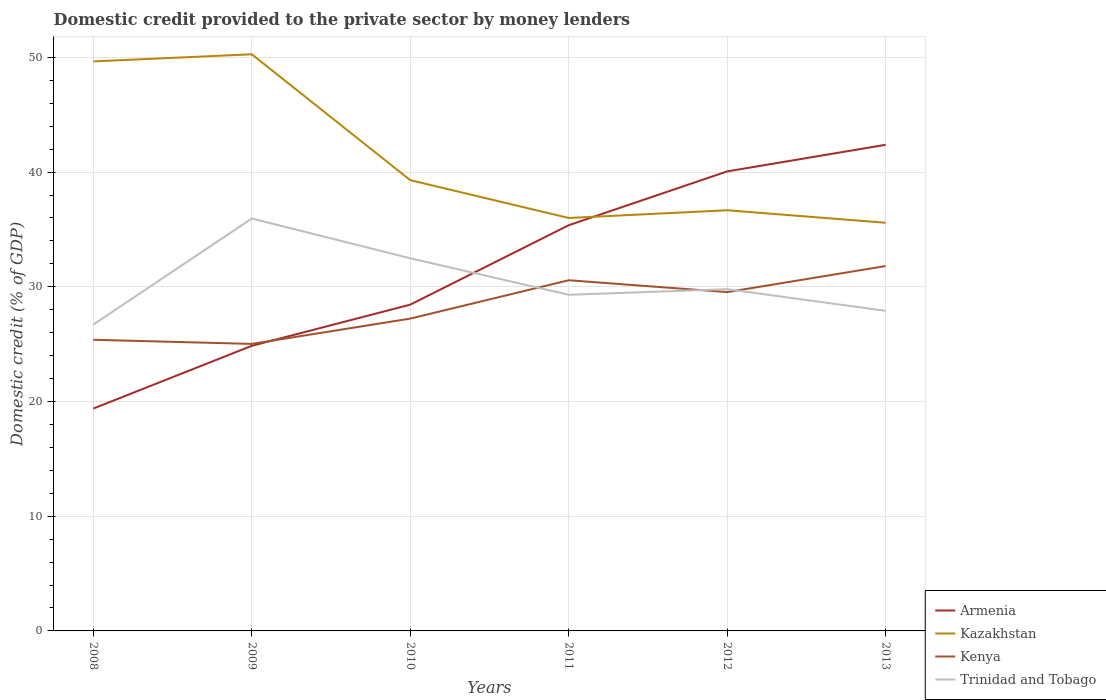Is the number of lines equal to the number of legend labels?
Your answer should be very brief. Yes. Across all years, what is the maximum domestic credit provided to the private sector by money lenders in Kazakhstan?
Give a very brief answer. 35.58. What is the total domestic credit provided to the private sector by money lenders in Kazakhstan in the graph?
Provide a succinct answer. 14.27. What is the difference between the highest and the second highest domestic credit provided to the private sector by money lenders in Armenia?
Give a very brief answer. 22.99. How many lines are there?
Provide a short and direct response. 4. How are the legend labels stacked?
Ensure brevity in your answer.  Vertical. What is the title of the graph?
Ensure brevity in your answer.  Domestic credit provided to the private sector by money lenders. Does "Sint Maarten (Dutch part)" appear as one of the legend labels in the graph?
Your answer should be very brief. No. What is the label or title of the X-axis?
Keep it short and to the point. Years. What is the label or title of the Y-axis?
Your answer should be very brief. Domestic credit (% of GDP). What is the Domestic credit (% of GDP) of Armenia in 2008?
Keep it short and to the point. 19.39. What is the Domestic credit (% of GDP) of Kazakhstan in 2008?
Your answer should be very brief. 49.65. What is the Domestic credit (% of GDP) in Kenya in 2008?
Give a very brief answer. 25.38. What is the Domestic credit (% of GDP) of Trinidad and Tobago in 2008?
Provide a succinct answer. 26.71. What is the Domestic credit (% of GDP) in Armenia in 2009?
Provide a succinct answer. 24.85. What is the Domestic credit (% of GDP) of Kazakhstan in 2009?
Provide a short and direct response. 50.27. What is the Domestic credit (% of GDP) in Kenya in 2009?
Keep it short and to the point. 25.02. What is the Domestic credit (% of GDP) of Trinidad and Tobago in 2009?
Offer a very short reply. 35.95. What is the Domestic credit (% of GDP) of Armenia in 2010?
Offer a very short reply. 28.45. What is the Domestic credit (% of GDP) of Kazakhstan in 2010?
Your answer should be very brief. 39.3. What is the Domestic credit (% of GDP) of Kenya in 2010?
Give a very brief answer. 27.23. What is the Domestic credit (% of GDP) of Trinidad and Tobago in 2010?
Your answer should be very brief. 32.49. What is the Domestic credit (% of GDP) of Armenia in 2011?
Keep it short and to the point. 35.37. What is the Domestic credit (% of GDP) of Kazakhstan in 2011?
Ensure brevity in your answer.  36. What is the Domestic credit (% of GDP) in Kenya in 2011?
Your answer should be compact. 30.57. What is the Domestic credit (% of GDP) in Trinidad and Tobago in 2011?
Provide a succinct answer. 29.3. What is the Domestic credit (% of GDP) in Armenia in 2012?
Your answer should be compact. 40.06. What is the Domestic credit (% of GDP) in Kazakhstan in 2012?
Provide a short and direct response. 36.67. What is the Domestic credit (% of GDP) in Kenya in 2012?
Ensure brevity in your answer.  29.54. What is the Domestic credit (% of GDP) of Trinidad and Tobago in 2012?
Give a very brief answer. 29.79. What is the Domestic credit (% of GDP) in Armenia in 2013?
Ensure brevity in your answer.  42.38. What is the Domestic credit (% of GDP) in Kazakhstan in 2013?
Make the answer very short. 35.58. What is the Domestic credit (% of GDP) in Kenya in 2013?
Make the answer very short. 31.81. What is the Domestic credit (% of GDP) in Trinidad and Tobago in 2013?
Provide a short and direct response. 27.91. Across all years, what is the maximum Domestic credit (% of GDP) in Armenia?
Offer a terse response. 42.38. Across all years, what is the maximum Domestic credit (% of GDP) of Kazakhstan?
Your answer should be compact. 50.27. Across all years, what is the maximum Domestic credit (% of GDP) in Kenya?
Provide a short and direct response. 31.81. Across all years, what is the maximum Domestic credit (% of GDP) of Trinidad and Tobago?
Your response must be concise. 35.95. Across all years, what is the minimum Domestic credit (% of GDP) of Armenia?
Offer a very short reply. 19.39. Across all years, what is the minimum Domestic credit (% of GDP) of Kazakhstan?
Keep it short and to the point. 35.58. Across all years, what is the minimum Domestic credit (% of GDP) in Kenya?
Your answer should be very brief. 25.02. Across all years, what is the minimum Domestic credit (% of GDP) in Trinidad and Tobago?
Provide a short and direct response. 26.71. What is the total Domestic credit (% of GDP) of Armenia in the graph?
Keep it short and to the point. 190.5. What is the total Domestic credit (% of GDP) in Kazakhstan in the graph?
Make the answer very short. 247.47. What is the total Domestic credit (% of GDP) of Kenya in the graph?
Make the answer very short. 169.55. What is the total Domestic credit (% of GDP) of Trinidad and Tobago in the graph?
Provide a succinct answer. 182.15. What is the difference between the Domestic credit (% of GDP) in Armenia in 2008 and that in 2009?
Provide a short and direct response. -5.47. What is the difference between the Domestic credit (% of GDP) in Kazakhstan in 2008 and that in 2009?
Provide a succinct answer. -0.62. What is the difference between the Domestic credit (% of GDP) in Kenya in 2008 and that in 2009?
Your response must be concise. 0.36. What is the difference between the Domestic credit (% of GDP) in Trinidad and Tobago in 2008 and that in 2009?
Your answer should be very brief. -9.25. What is the difference between the Domestic credit (% of GDP) in Armenia in 2008 and that in 2010?
Make the answer very short. -9.06. What is the difference between the Domestic credit (% of GDP) in Kazakhstan in 2008 and that in 2010?
Offer a very short reply. 10.35. What is the difference between the Domestic credit (% of GDP) in Kenya in 2008 and that in 2010?
Provide a short and direct response. -1.85. What is the difference between the Domestic credit (% of GDP) of Trinidad and Tobago in 2008 and that in 2010?
Offer a terse response. -5.78. What is the difference between the Domestic credit (% of GDP) in Armenia in 2008 and that in 2011?
Provide a short and direct response. -15.98. What is the difference between the Domestic credit (% of GDP) in Kazakhstan in 2008 and that in 2011?
Provide a short and direct response. 13.65. What is the difference between the Domestic credit (% of GDP) in Kenya in 2008 and that in 2011?
Keep it short and to the point. -5.19. What is the difference between the Domestic credit (% of GDP) in Trinidad and Tobago in 2008 and that in 2011?
Provide a succinct answer. -2.6. What is the difference between the Domestic credit (% of GDP) in Armenia in 2008 and that in 2012?
Ensure brevity in your answer.  -20.67. What is the difference between the Domestic credit (% of GDP) of Kazakhstan in 2008 and that in 2012?
Your answer should be very brief. 12.97. What is the difference between the Domestic credit (% of GDP) of Kenya in 2008 and that in 2012?
Your answer should be very brief. -4.16. What is the difference between the Domestic credit (% of GDP) in Trinidad and Tobago in 2008 and that in 2012?
Offer a terse response. -3.08. What is the difference between the Domestic credit (% of GDP) of Armenia in 2008 and that in 2013?
Your answer should be compact. -22.99. What is the difference between the Domestic credit (% of GDP) of Kazakhstan in 2008 and that in 2013?
Your answer should be very brief. 14.07. What is the difference between the Domestic credit (% of GDP) of Kenya in 2008 and that in 2013?
Provide a succinct answer. -6.43. What is the difference between the Domestic credit (% of GDP) of Trinidad and Tobago in 2008 and that in 2013?
Provide a short and direct response. -1.2. What is the difference between the Domestic credit (% of GDP) of Armenia in 2009 and that in 2010?
Your answer should be very brief. -3.59. What is the difference between the Domestic credit (% of GDP) of Kazakhstan in 2009 and that in 2010?
Provide a short and direct response. 10.97. What is the difference between the Domestic credit (% of GDP) of Kenya in 2009 and that in 2010?
Offer a very short reply. -2.21. What is the difference between the Domestic credit (% of GDP) in Trinidad and Tobago in 2009 and that in 2010?
Provide a short and direct response. 3.47. What is the difference between the Domestic credit (% of GDP) in Armenia in 2009 and that in 2011?
Make the answer very short. -10.51. What is the difference between the Domestic credit (% of GDP) of Kazakhstan in 2009 and that in 2011?
Ensure brevity in your answer.  14.27. What is the difference between the Domestic credit (% of GDP) of Kenya in 2009 and that in 2011?
Offer a terse response. -5.55. What is the difference between the Domestic credit (% of GDP) in Trinidad and Tobago in 2009 and that in 2011?
Give a very brief answer. 6.65. What is the difference between the Domestic credit (% of GDP) of Armenia in 2009 and that in 2012?
Your answer should be very brief. -15.21. What is the difference between the Domestic credit (% of GDP) in Kazakhstan in 2009 and that in 2012?
Ensure brevity in your answer.  13.6. What is the difference between the Domestic credit (% of GDP) in Kenya in 2009 and that in 2012?
Offer a very short reply. -4.52. What is the difference between the Domestic credit (% of GDP) of Trinidad and Tobago in 2009 and that in 2012?
Make the answer very short. 6.16. What is the difference between the Domestic credit (% of GDP) of Armenia in 2009 and that in 2013?
Offer a very short reply. -17.53. What is the difference between the Domestic credit (% of GDP) of Kazakhstan in 2009 and that in 2013?
Your answer should be very brief. 14.69. What is the difference between the Domestic credit (% of GDP) of Kenya in 2009 and that in 2013?
Ensure brevity in your answer.  -6.79. What is the difference between the Domestic credit (% of GDP) in Trinidad and Tobago in 2009 and that in 2013?
Make the answer very short. 8.05. What is the difference between the Domestic credit (% of GDP) in Armenia in 2010 and that in 2011?
Ensure brevity in your answer.  -6.92. What is the difference between the Domestic credit (% of GDP) of Kazakhstan in 2010 and that in 2011?
Provide a succinct answer. 3.3. What is the difference between the Domestic credit (% of GDP) in Kenya in 2010 and that in 2011?
Your answer should be very brief. -3.34. What is the difference between the Domestic credit (% of GDP) of Trinidad and Tobago in 2010 and that in 2011?
Your answer should be compact. 3.18. What is the difference between the Domestic credit (% of GDP) of Armenia in 2010 and that in 2012?
Your answer should be compact. -11.61. What is the difference between the Domestic credit (% of GDP) of Kazakhstan in 2010 and that in 2012?
Provide a succinct answer. 2.62. What is the difference between the Domestic credit (% of GDP) of Kenya in 2010 and that in 2012?
Make the answer very short. -2.31. What is the difference between the Domestic credit (% of GDP) in Trinidad and Tobago in 2010 and that in 2012?
Provide a succinct answer. 2.7. What is the difference between the Domestic credit (% of GDP) of Armenia in 2010 and that in 2013?
Your answer should be very brief. -13.94. What is the difference between the Domestic credit (% of GDP) in Kazakhstan in 2010 and that in 2013?
Offer a very short reply. 3.71. What is the difference between the Domestic credit (% of GDP) of Kenya in 2010 and that in 2013?
Offer a terse response. -4.58. What is the difference between the Domestic credit (% of GDP) of Trinidad and Tobago in 2010 and that in 2013?
Keep it short and to the point. 4.58. What is the difference between the Domestic credit (% of GDP) in Armenia in 2011 and that in 2012?
Offer a very short reply. -4.69. What is the difference between the Domestic credit (% of GDP) of Kazakhstan in 2011 and that in 2012?
Offer a terse response. -0.67. What is the difference between the Domestic credit (% of GDP) of Kenya in 2011 and that in 2012?
Make the answer very short. 1.03. What is the difference between the Domestic credit (% of GDP) in Trinidad and Tobago in 2011 and that in 2012?
Offer a very short reply. -0.49. What is the difference between the Domestic credit (% of GDP) in Armenia in 2011 and that in 2013?
Ensure brevity in your answer.  -7.01. What is the difference between the Domestic credit (% of GDP) of Kazakhstan in 2011 and that in 2013?
Offer a terse response. 0.42. What is the difference between the Domestic credit (% of GDP) of Kenya in 2011 and that in 2013?
Your answer should be very brief. -1.24. What is the difference between the Domestic credit (% of GDP) in Trinidad and Tobago in 2011 and that in 2013?
Your answer should be very brief. 1.4. What is the difference between the Domestic credit (% of GDP) of Armenia in 2012 and that in 2013?
Provide a succinct answer. -2.32. What is the difference between the Domestic credit (% of GDP) in Kazakhstan in 2012 and that in 2013?
Your response must be concise. 1.09. What is the difference between the Domestic credit (% of GDP) of Kenya in 2012 and that in 2013?
Provide a short and direct response. -2.27. What is the difference between the Domestic credit (% of GDP) in Trinidad and Tobago in 2012 and that in 2013?
Your answer should be compact. 1.88. What is the difference between the Domestic credit (% of GDP) in Armenia in 2008 and the Domestic credit (% of GDP) in Kazakhstan in 2009?
Your response must be concise. -30.88. What is the difference between the Domestic credit (% of GDP) in Armenia in 2008 and the Domestic credit (% of GDP) in Kenya in 2009?
Make the answer very short. -5.63. What is the difference between the Domestic credit (% of GDP) in Armenia in 2008 and the Domestic credit (% of GDP) in Trinidad and Tobago in 2009?
Your answer should be compact. -16.57. What is the difference between the Domestic credit (% of GDP) in Kazakhstan in 2008 and the Domestic credit (% of GDP) in Kenya in 2009?
Ensure brevity in your answer.  24.63. What is the difference between the Domestic credit (% of GDP) in Kazakhstan in 2008 and the Domestic credit (% of GDP) in Trinidad and Tobago in 2009?
Ensure brevity in your answer.  13.69. What is the difference between the Domestic credit (% of GDP) of Kenya in 2008 and the Domestic credit (% of GDP) of Trinidad and Tobago in 2009?
Make the answer very short. -10.57. What is the difference between the Domestic credit (% of GDP) of Armenia in 2008 and the Domestic credit (% of GDP) of Kazakhstan in 2010?
Give a very brief answer. -19.91. What is the difference between the Domestic credit (% of GDP) of Armenia in 2008 and the Domestic credit (% of GDP) of Kenya in 2010?
Provide a short and direct response. -7.84. What is the difference between the Domestic credit (% of GDP) of Armenia in 2008 and the Domestic credit (% of GDP) of Trinidad and Tobago in 2010?
Offer a terse response. -13.1. What is the difference between the Domestic credit (% of GDP) of Kazakhstan in 2008 and the Domestic credit (% of GDP) of Kenya in 2010?
Provide a short and direct response. 22.42. What is the difference between the Domestic credit (% of GDP) of Kazakhstan in 2008 and the Domestic credit (% of GDP) of Trinidad and Tobago in 2010?
Your response must be concise. 17.16. What is the difference between the Domestic credit (% of GDP) of Kenya in 2008 and the Domestic credit (% of GDP) of Trinidad and Tobago in 2010?
Your answer should be very brief. -7.11. What is the difference between the Domestic credit (% of GDP) of Armenia in 2008 and the Domestic credit (% of GDP) of Kazakhstan in 2011?
Give a very brief answer. -16.61. What is the difference between the Domestic credit (% of GDP) in Armenia in 2008 and the Domestic credit (% of GDP) in Kenya in 2011?
Make the answer very short. -11.19. What is the difference between the Domestic credit (% of GDP) in Armenia in 2008 and the Domestic credit (% of GDP) in Trinidad and Tobago in 2011?
Keep it short and to the point. -9.92. What is the difference between the Domestic credit (% of GDP) in Kazakhstan in 2008 and the Domestic credit (% of GDP) in Kenya in 2011?
Make the answer very short. 19.07. What is the difference between the Domestic credit (% of GDP) in Kazakhstan in 2008 and the Domestic credit (% of GDP) in Trinidad and Tobago in 2011?
Your answer should be compact. 20.34. What is the difference between the Domestic credit (% of GDP) in Kenya in 2008 and the Domestic credit (% of GDP) in Trinidad and Tobago in 2011?
Provide a short and direct response. -3.92. What is the difference between the Domestic credit (% of GDP) of Armenia in 2008 and the Domestic credit (% of GDP) of Kazakhstan in 2012?
Provide a short and direct response. -17.29. What is the difference between the Domestic credit (% of GDP) of Armenia in 2008 and the Domestic credit (% of GDP) of Kenya in 2012?
Make the answer very short. -10.15. What is the difference between the Domestic credit (% of GDP) in Armenia in 2008 and the Domestic credit (% of GDP) in Trinidad and Tobago in 2012?
Provide a short and direct response. -10.4. What is the difference between the Domestic credit (% of GDP) of Kazakhstan in 2008 and the Domestic credit (% of GDP) of Kenya in 2012?
Your answer should be compact. 20.11. What is the difference between the Domestic credit (% of GDP) in Kazakhstan in 2008 and the Domestic credit (% of GDP) in Trinidad and Tobago in 2012?
Your response must be concise. 19.86. What is the difference between the Domestic credit (% of GDP) in Kenya in 2008 and the Domestic credit (% of GDP) in Trinidad and Tobago in 2012?
Provide a short and direct response. -4.41. What is the difference between the Domestic credit (% of GDP) of Armenia in 2008 and the Domestic credit (% of GDP) of Kazakhstan in 2013?
Ensure brevity in your answer.  -16.2. What is the difference between the Domestic credit (% of GDP) of Armenia in 2008 and the Domestic credit (% of GDP) of Kenya in 2013?
Offer a terse response. -12.42. What is the difference between the Domestic credit (% of GDP) of Armenia in 2008 and the Domestic credit (% of GDP) of Trinidad and Tobago in 2013?
Ensure brevity in your answer.  -8.52. What is the difference between the Domestic credit (% of GDP) of Kazakhstan in 2008 and the Domestic credit (% of GDP) of Kenya in 2013?
Your answer should be compact. 17.84. What is the difference between the Domestic credit (% of GDP) in Kazakhstan in 2008 and the Domestic credit (% of GDP) in Trinidad and Tobago in 2013?
Ensure brevity in your answer.  21.74. What is the difference between the Domestic credit (% of GDP) of Kenya in 2008 and the Domestic credit (% of GDP) of Trinidad and Tobago in 2013?
Your answer should be very brief. -2.52. What is the difference between the Domestic credit (% of GDP) in Armenia in 2009 and the Domestic credit (% of GDP) in Kazakhstan in 2010?
Your response must be concise. -14.44. What is the difference between the Domestic credit (% of GDP) of Armenia in 2009 and the Domestic credit (% of GDP) of Kenya in 2010?
Offer a terse response. -2.37. What is the difference between the Domestic credit (% of GDP) of Armenia in 2009 and the Domestic credit (% of GDP) of Trinidad and Tobago in 2010?
Keep it short and to the point. -7.63. What is the difference between the Domestic credit (% of GDP) of Kazakhstan in 2009 and the Domestic credit (% of GDP) of Kenya in 2010?
Your answer should be very brief. 23.04. What is the difference between the Domestic credit (% of GDP) in Kazakhstan in 2009 and the Domestic credit (% of GDP) in Trinidad and Tobago in 2010?
Offer a terse response. 17.78. What is the difference between the Domestic credit (% of GDP) of Kenya in 2009 and the Domestic credit (% of GDP) of Trinidad and Tobago in 2010?
Provide a succinct answer. -7.47. What is the difference between the Domestic credit (% of GDP) of Armenia in 2009 and the Domestic credit (% of GDP) of Kazakhstan in 2011?
Give a very brief answer. -11.14. What is the difference between the Domestic credit (% of GDP) of Armenia in 2009 and the Domestic credit (% of GDP) of Kenya in 2011?
Your response must be concise. -5.72. What is the difference between the Domestic credit (% of GDP) in Armenia in 2009 and the Domestic credit (% of GDP) in Trinidad and Tobago in 2011?
Your answer should be very brief. -4.45. What is the difference between the Domestic credit (% of GDP) in Kazakhstan in 2009 and the Domestic credit (% of GDP) in Kenya in 2011?
Offer a terse response. 19.7. What is the difference between the Domestic credit (% of GDP) in Kazakhstan in 2009 and the Domestic credit (% of GDP) in Trinidad and Tobago in 2011?
Ensure brevity in your answer.  20.97. What is the difference between the Domestic credit (% of GDP) in Kenya in 2009 and the Domestic credit (% of GDP) in Trinidad and Tobago in 2011?
Offer a terse response. -4.28. What is the difference between the Domestic credit (% of GDP) in Armenia in 2009 and the Domestic credit (% of GDP) in Kazakhstan in 2012?
Give a very brief answer. -11.82. What is the difference between the Domestic credit (% of GDP) of Armenia in 2009 and the Domestic credit (% of GDP) of Kenya in 2012?
Provide a succinct answer. -4.68. What is the difference between the Domestic credit (% of GDP) in Armenia in 2009 and the Domestic credit (% of GDP) in Trinidad and Tobago in 2012?
Make the answer very short. -4.94. What is the difference between the Domestic credit (% of GDP) of Kazakhstan in 2009 and the Domestic credit (% of GDP) of Kenya in 2012?
Provide a short and direct response. 20.73. What is the difference between the Domestic credit (% of GDP) in Kazakhstan in 2009 and the Domestic credit (% of GDP) in Trinidad and Tobago in 2012?
Your answer should be very brief. 20.48. What is the difference between the Domestic credit (% of GDP) of Kenya in 2009 and the Domestic credit (% of GDP) of Trinidad and Tobago in 2012?
Offer a very short reply. -4.77. What is the difference between the Domestic credit (% of GDP) of Armenia in 2009 and the Domestic credit (% of GDP) of Kazakhstan in 2013?
Provide a short and direct response. -10.73. What is the difference between the Domestic credit (% of GDP) in Armenia in 2009 and the Domestic credit (% of GDP) in Kenya in 2013?
Your answer should be very brief. -6.95. What is the difference between the Domestic credit (% of GDP) in Armenia in 2009 and the Domestic credit (% of GDP) in Trinidad and Tobago in 2013?
Your response must be concise. -3.05. What is the difference between the Domestic credit (% of GDP) in Kazakhstan in 2009 and the Domestic credit (% of GDP) in Kenya in 2013?
Give a very brief answer. 18.46. What is the difference between the Domestic credit (% of GDP) in Kazakhstan in 2009 and the Domestic credit (% of GDP) in Trinidad and Tobago in 2013?
Your response must be concise. 22.36. What is the difference between the Domestic credit (% of GDP) of Kenya in 2009 and the Domestic credit (% of GDP) of Trinidad and Tobago in 2013?
Your answer should be very brief. -2.88. What is the difference between the Domestic credit (% of GDP) of Armenia in 2010 and the Domestic credit (% of GDP) of Kazakhstan in 2011?
Keep it short and to the point. -7.55. What is the difference between the Domestic credit (% of GDP) in Armenia in 2010 and the Domestic credit (% of GDP) in Kenya in 2011?
Your answer should be compact. -2.13. What is the difference between the Domestic credit (% of GDP) in Armenia in 2010 and the Domestic credit (% of GDP) in Trinidad and Tobago in 2011?
Keep it short and to the point. -0.86. What is the difference between the Domestic credit (% of GDP) in Kazakhstan in 2010 and the Domestic credit (% of GDP) in Kenya in 2011?
Keep it short and to the point. 8.72. What is the difference between the Domestic credit (% of GDP) in Kazakhstan in 2010 and the Domestic credit (% of GDP) in Trinidad and Tobago in 2011?
Make the answer very short. 9.99. What is the difference between the Domestic credit (% of GDP) of Kenya in 2010 and the Domestic credit (% of GDP) of Trinidad and Tobago in 2011?
Provide a short and direct response. -2.08. What is the difference between the Domestic credit (% of GDP) in Armenia in 2010 and the Domestic credit (% of GDP) in Kazakhstan in 2012?
Give a very brief answer. -8.23. What is the difference between the Domestic credit (% of GDP) in Armenia in 2010 and the Domestic credit (% of GDP) in Kenya in 2012?
Offer a very short reply. -1.09. What is the difference between the Domestic credit (% of GDP) of Armenia in 2010 and the Domestic credit (% of GDP) of Trinidad and Tobago in 2012?
Your response must be concise. -1.34. What is the difference between the Domestic credit (% of GDP) of Kazakhstan in 2010 and the Domestic credit (% of GDP) of Kenya in 2012?
Provide a short and direct response. 9.76. What is the difference between the Domestic credit (% of GDP) of Kazakhstan in 2010 and the Domestic credit (% of GDP) of Trinidad and Tobago in 2012?
Your answer should be very brief. 9.51. What is the difference between the Domestic credit (% of GDP) of Kenya in 2010 and the Domestic credit (% of GDP) of Trinidad and Tobago in 2012?
Make the answer very short. -2.56. What is the difference between the Domestic credit (% of GDP) of Armenia in 2010 and the Domestic credit (% of GDP) of Kazakhstan in 2013?
Ensure brevity in your answer.  -7.14. What is the difference between the Domestic credit (% of GDP) in Armenia in 2010 and the Domestic credit (% of GDP) in Kenya in 2013?
Your response must be concise. -3.36. What is the difference between the Domestic credit (% of GDP) of Armenia in 2010 and the Domestic credit (% of GDP) of Trinidad and Tobago in 2013?
Your answer should be very brief. 0.54. What is the difference between the Domestic credit (% of GDP) of Kazakhstan in 2010 and the Domestic credit (% of GDP) of Kenya in 2013?
Make the answer very short. 7.49. What is the difference between the Domestic credit (% of GDP) of Kazakhstan in 2010 and the Domestic credit (% of GDP) of Trinidad and Tobago in 2013?
Your answer should be very brief. 11.39. What is the difference between the Domestic credit (% of GDP) of Kenya in 2010 and the Domestic credit (% of GDP) of Trinidad and Tobago in 2013?
Your answer should be very brief. -0.68. What is the difference between the Domestic credit (% of GDP) of Armenia in 2011 and the Domestic credit (% of GDP) of Kazakhstan in 2012?
Keep it short and to the point. -1.31. What is the difference between the Domestic credit (% of GDP) of Armenia in 2011 and the Domestic credit (% of GDP) of Kenya in 2012?
Your answer should be compact. 5.83. What is the difference between the Domestic credit (% of GDP) of Armenia in 2011 and the Domestic credit (% of GDP) of Trinidad and Tobago in 2012?
Offer a very short reply. 5.58. What is the difference between the Domestic credit (% of GDP) of Kazakhstan in 2011 and the Domestic credit (% of GDP) of Kenya in 2012?
Your answer should be very brief. 6.46. What is the difference between the Domestic credit (% of GDP) of Kazakhstan in 2011 and the Domestic credit (% of GDP) of Trinidad and Tobago in 2012?
Your answer should be very brief. 6.21. What is the difference between the Domestic credit (% of GDP) in Kenya in 2011 and the Domestic credit (% of GDP) in Trinidad and Tobago in 2012?
Provide a succinct answer. 0.78. What is the difference between the Domestic credit (% of GDP) in Armenia in 2011 and the Domestic credit (% of GDP) in Kazakhstan in 2013?
Offer a terse response. -0.21. What is the difference between the Domestic credit (% of GDP) of Armenia in 2011 and the Domestic credit (% of GDP) of Kenya in 2013?
Keep it short and to the point. 3.56. What is the difference between the Domestic credit (% of GDP) of Armenia in 2011 and the Domestic credit (% of GDP) of Trinidad and Tobago in 2013?
Provide a short and direct response. 7.46. What is the difference between the Domestic credit (% of GDP) in Kazakhstan in 2011 and the Domestic credit (% of GDP) in Kenya in 2013?
Keep it short and to the point. 4.19. What is the difference between the Domestic credit (% of GDP) of Kazakhstan in 2011 and the Domestic credit (% of GDP) of Trinidad and Tobago in 2013?
Offer a very short reply. 8.09. What is the difference between the Domestic credit (% of GDP) in Kenya in 2011 and the Domestic credit (% of GDP) in Trinidad and Tobago in 2013?
Your response must be concise. 2.67. What is the difference between the Domestic credit (% of GDP) of Armenia in 2012 and the Domestic credit (% of GDP) of Kazakhstan in 2013?
Offer a very short reply. 4.48. What is the difference between the Domestic credit (% of GDP) in Armenia in 2012 and the Domestic credit (% of GDP) in Kenya in 2013?
Offer a very short reply. 8.25. What is the difference between the Domestic credit (% of GDP) of Armenia in 2012 and the Domestic credit (% of GDP) of Trinidad and Tobago in 2013?
Offer a very short reply. 12.15. What is the difference between the Domestic credit (% of GDP) in Kazakhstan in 2012 and the Domestic credit (% of GDP) in Kenya in 2013?
Your answer should be compact. 4.86. What is the difference between the Domestic credit (% of GDP) in Kazakhstan in 2012 and the Domestic credit (% of GDP) in Trinidad and Tobago in 2013?
Provide a short and direct response. 8.77. What is the difference between the Domestic credit (% of GDP) of Kenya in 2012 and the Domestic credit (% of GDP) of Trinidad and Tobago in 2013?
Provide a succinct answer. 1.63. What is the average Domestic credit (% of GDP) in Armenia per year?
Make the answer very short. 31.75. What is the average Domestic credit (% of GDP) of Kazakhstan per year?
Provide a succinct answer. 41.24. What is the average Domestic credit (% of GDP) in Kenya per year?
Give a very brief answer. 28.26. What is the average Domestic credit (% of GDP) of Trinidad and Tobago per year?
Offer a very short reply. 30.36. In the year 2008, what is the difference between the Domestic credit (% of GDP) in Armenia and Domestic credit (% of GDP) in Kazakhstan?
Keep it short and to the point. -30.26. In the year 2008, what is the difference between the Domestic credit (% of GDP) in Armenia and Domestic credit (% of GDP) in Kenya?
Your response must be concise. -5.99. In the year 2008, what is the difference between the Domestic credit (% of GDP) of Armenia and Domestic credit (% of GDP) of Trinidad and Tobago?
Ensure brevity in your answer.  -7.32. In the year 2008, what is the difference between the Domestic credit (% of GDP) in Kazakhstan and Domestic credit (% of GDP) in Kenya?
Give a very brief answer. 24.27. In the year 2008, what is the difference between the Domestic credit (% of GDP) in Kazakhstan and Domestic credit (% of GDP) in Trinidad and Tobago?
Provide a succinct answer. 22.94. In the year 2008, what is the difference between the Domestic credit (% of GDP) in Kenya and Domestic credit (% of GDP) in Trinidad and Tobago?
Keep it short and to the point. -1.33. In the year 2009, what is the difference between the Domestic credit (% of GDP) of Armenia and Domestic credit (% of GDP) of Kazakhstan?
Provide a short and direct response. -25.41. In the year 2009, what is the difference between the Domestic credit (% of GDP) of Armenia and Domestic credit (% of GDP) of Kenya?
Offer a very short reply. -0.17. In the year 2009, what is the difference between the Domestic credit (% of GDP) in Armenia and Domestic credit (% of GDP) in Trinidad and Tobago?
Your response must be concise. -11.1. In the year 2009, what is the difference between the Domestic credit (% of GDP) in Kazakhstan and Domestic credit (% of GDP) in Kenya?
Provide a succinct answer. 25.25. In the year 2009, what is the difference between the Domestic credit (% of GDP) in Kazakhstan and Domestic credit (% of GDP) in Trinidad and Tobago?
Offer a terse response. 14.32. In the year 2009, what is the difference between the Domestic credit (% of GDP) in Kenya and Domestic credit (% of GDP) in Trinidad and Tobago?
Give a very brief answer. -10.93. In the year 2010, what is the difference between the Domestic credit (% of GDP) of Armenia and Domestic credit (% of GDP) of Kazakhstan?
Give a very brief answer. -10.85. In the year 2010, what is the difference between the Domestic credit (% of GDP) in Armenia and Domestic credit (% of GDP) in Kenya?
Your answer should be compact. 1.22. In the year 2010, what is the difference between the Domestic credit (% of GDP) in Armenia and Domestic credit (% of GDP) in Trinidad and Tobago?
Give a very brief answer. -4.04. In the year 2010, what is the difference between the Domestic credit (% of GDP) of Kazakhstan and Domestic credit (% of GDP) of Kenya?
Offer a terse response. 12.07. In the year 2010, what is the difference between the Domestic credit (% of GDP) of Kazakhstan and Domestic credit (% of GDP) of Trinidad and Tobago?
Keep it short and to the point. 6.81. In the year 2010, what is the difference between the Domestic credit (% of GDP) in Kenya and Domestic credit (% of GDP) in Trinidad and Tobago?
Offer a very short reply. -5.26. In the year 2011, what is the difference between the Domestic credit (% of GDP) of Armenia and Domestic credit (% of GDP) of Kazakhstan?
Offer a very short reply. -0.63. In the year 2011, what is the difference between the Domestic credit (% of GDP) in Armenia and Domestic credit (% of GDP) in Kenya?
Your response must be concise. 4.8. In the year 2011, what is the difference between the Domestic credit (% of GDP) in Armenia and Domestic credit (% of GDP) in Trinidad and Tobago?
Give a very brief answer. 6.06. In the year 2011, what is the difference between the Domestic credit (% of GDP) in Kazakhstan and Domestic credit (% of GDP) in Kenya?
Your answer should be compact. 5.43. In the year 2011, what is the difference between the Domestic credit (% of GDP) of Kazakhstan and Domestic credit (% of GDP) of Trinidad and Tobago?
Your answer should be compact. 6.7. In the year 2011, what is the difference between the Domestic credit (% of GDP) in Kenya and Domestic credit (% of GDP) in Trinidad and Tobago?
Provide a succinct answer. 1.27. In the year 2012, what is the difference between the Domestic credit (% of GDP) in Armenia and Domestic credit (% of GDP) in Kazakhstan?
Provide a short and direct response. 3.39. In the year 2012, what is the difference between the Domestic credit (% of GDP) in Armenia and Domestic credit (% of GDP) in Kenya?
Provide a short and direct response. 10.52. In the year 2012, what is the difference between the Domestic credit (% of GDP) in Armenia and Domestic credit (% of GDP) in Trinidad and Tobago?
Offer a very short reply. 10.27. In the year 2012, what is the difference between the Domestic credit (% of GDP) in Kazakhstan and Domestic credit (% of GDP) in Kenya?
Provide a short and direct response. 7.14. In the year 2012, what is the difference between the Domestic credit (% of GDP) of Kazakhstan and Domestic credit (% of GDP) of Trinidad and Tobago?
Offer a very short reply. 6.88. In the year 2012, what is the difference between the Domestic credit (% of GDP) in Kenya and Domestic credit (% of GDP) in Trinidad and Tobago?
Your response must be concise. -0.25. In the year 2013, what is the difference between the Domestic credit (% of GDP) in Armenia and Domestic credit (% of GDP) in Kazakhstan?
Give a very brief answer. 6.8. In the year 2013, what is the difference between the Domestic credit (% of GDP) of Armenia and Domestic credit (% of GDP) of Kenya?
Your answer should be compact. 10.57. In the year 2013, what is the difference between the Domestic credit (% of GDP) in Armenia and Domestic credit (% of GDP) in Trinidad and Tobago?
Your answer should be compact. 14.47. In the year 2013, what is the difference between the Domestic credit (% of GDP) of Kazakhstan and Domestic credit (% of GDP) of Kenya?
Make the answer very short. 3.77. In the year 2013, what is the difference between the Domestic credit (% of GDP) in Kazakhstan and Domestic credit (% of GDP) in Trinidad and Tobago?
Your answer should be compact. 7.68. In the year 2013, what is the difference between the Domestic credit (% of GDP) in Kenya and Domestic credit (% of GDP) in Trinidad and Tobago?
Offer a very short reply. 3.9. What is the ratio of the Domestic credit (% of GDP) of Armenia in 2008 to that in 2009?
Ensure brevity in your answer.  0.78. What is the ratio of the Domestic credit (% of GDP) in Kazakhstan in 2008 to that in 2009?
Your answer should be very brief. 0.99. What is the ratio of the Domestic credit (% of GDP) in Kenya in 2008 to that in 2009?
Ensure brevity in your answer.  1.01. What is the ratio of the Domestic credit (% of GDP) in Trinidad and Tobago in 2008 to that in 2009?
Offer a very short reply. 0.74. What is the ratio of the Domestic credit (% of GDP) of Armenia in 2008 to that in 2010?
Your answer should be very brief. 0.68. What is the ratio of the Domestic credit (% of GDP) in Kazakhstan in 2008 to that in 2010?
Your response must be concise. 1.26. What is the ratio of the Domestic credit (% of GDP) of Kenya in 2008 to that in 2010?
Provide a short and direct response. 0.93. What is the ratio of the Domestic credit (% of GDP) of Trinidad and Tobago in 2008 to that in 2010?
Your answer should be very brief. 0.82. What is the ratio of the Domestic credit (% of GDP) of Armenia in 2008 to that in 2011?
Provide a succinct answer. 0.55. What is the ratio of the Domestic credit (% of GDP) in Kazakhstan in 2008 to that in 2011?
Offer a very short reply. 1.38. What is the ratio of the Domestic credit (% of GDP) in Kenya in 2008 to that in 2011?
Your answer should be compact. 0.83. What is the ratio of the Domestic credit (% of GDP) of Trinidad and Tobago in 2008 to that in 2011?
Keep it short and to the point. 0.91. What is the ratio of the Domestic credit (% of GDP) in Armenia in 2008 to that in 2012?
Ensure brevity in your answer.  0.48. What is the ratio of the Domestic credit (% of GDP) of Kazakhstan in 2008 to that in 2012?
Your response must be concise. 1.35. What is the ratio of the Domestic credit (% of GDP) in Kenya in 2008 to that in 2012?
Make the answer very short. 0.86. What is the ratio of the Domestic credit (% of GDP) in Trinidad and Tobago in 2008 to that in 2012?
Provide a succinct answer. 0.9. What is the ratio of the Domestic credit (% of GDP) in Armenia in 2008 to that in 2013?
Give a very brief answer. 0.46. What is the ratio of the Domestic credit (% of GDP) in Kazakhstan in 2008 to that in 2013?
Offer a very short reply. 1.4. What is the ratio of the Domestic credit (% of GDP) in Kenya in 2008 to that in 2013?
Provide a short and direct response. 0.8. What is the ratio of the Domestic credit (% of GDP) of Trinidad and Tobago in 2008 to that in 2013?
Keep it short and to the point. 0.96. What is the ratio of the Domestic credit (% of GDP) in Armenia in 2009 to that in 2010?
Give a very brief answer. 0.87. What is the ratio of the Domestic credit (% of GDP) of Kazakhstan in 2009 to that in 2010?
Offer a terse response. 1.28. What is the ratio of the Domestic credit (% of GDP) in Kenya in 2009 to that in 2010?
Your response must be concise. 0.92. What is the ratio of the Domestic credit (% of GDP) of Trinidad and Tobago in 2009 to that in 2010?
Give a very brief answer. 1.11. What is the ratio of the Domestic credit (% of GDP) in Armenia in 2009 to that in 2011?
Provide a short and direct response. 0.7. What is the ratio of the Domestic credit (% of GDP) of Kazakhstan in 2009 to that in 2011?
Provide a short and direct response. 1.4. What is the ratio of the Domestic credit (% of GDP) in Kenya in 2009 to that in 2011?
Your answer should be very brief. 0.82. What is the ratio of the Domestic credit (% of GDP) in Trinidad and Tobago in 2009 to that in 2011?
Your answer should be very brief. 1.23. What is the ratio of the Domestic credit (% of GDP) in Armenia in 2009 to that in 2012?
Your answer should be compact. 0.62. What is the ratio of the Domestic credit (% of GDP) in Kazakhstan in 2009 to that in 2012?
Offer a very short reply. 1.37. What is the ratio of the Domestic credit (% of GDP) of Kenya in 2009 to that in 2012?
Your answer should be very brief. 0.85. What is the ratio of the Domestic credit (% of GDP) of Trinidad and Tobago in 2009 to that in 2012?
Give a very brief answer. 1.21. What is the ratio of the Domestic credit (% of GDP) in Armenia in 2009 to that in 2013?
Ensure brevity in your answer.  0.59. What is the ratio of the Domestic credit (% of GDP) in Kazakhstan in 2009 to that in 2013?
Offer a very short reply. 1.41. What is the ratio of the Domestic credit (% of GDP) of Kenya in 2009 to that in 2013?
Offer a terse response. 0.79. What is the ratio of the Domestic credit (% of GDP) in Trinidad and Tobago in 2009 to that in 2013?
Offer a terse response. 1.29. What is the ratio of the Domestic credit (% of GDP) of Armenia in 2010 to that in 2011?
Your answer should be compact. 0.8. What is the ratio of the Domestic credit (% of GDP) of Kazakhstan in 2010 to that in 2011?
Give a very brief answer. 1.09. What is the ratio of the Domestic credit (% of GDP) of Kenya in 2010 to that in 2011?
Provide a succinct answer. 0.89. What is the ratio of the Domestic credit (% of GDP) of Trinidad and Tobago in 2010 to that in 2011?
Keep it short and to the point. 1.11. What is the ratio of the Domestic credit (% of GDP) of Armenia in 2010 to that in 2012?
Your answer should be very brief. 0.71. What is the ratio of the Domestic credit (% of GDP) of Kazakhstan in 2010 to that in 2012?
Keep it short and to the point. 1.07. What is the ratio of the Domestic credit (% of GDP) in Kenya in 2010 to that in 2012?
Your answer should be compact. 0.92. What is the ratio of the Domestic credit (% of GDP) of Trinidad and Tobago in 2010 to that in 2012?
Keep it short and to the point. 1.09. What is the ratio of the Domestic credit (% of GDP) of Armenia in 2010 to that in 2013?
Make the answer very short. 0.67. What is the ratio of the Domestic credit (% of GDP) of Kazakhstan in 2010 to that in 2013?
Provide a short and direct response. 1.1. What is the ratio of the Domestic credit (% of GDP) of Kenya in 2010 to that in 2013?
Your answer should be very brief. 0.86. What is the ratio of the Domestic credit (% of GDP) of Trinidad and Tobago in 2010 to that in 2013?
Your response must be concise. 1.16. What is the ratio of the Domestic credit (% of GDP) in Armenia in 2011 to that in 2012?
Ensure brevity in your answer.  0.88. What is the ratio of the Domestic credit (% of GDP) in Kazakhstan in 2011 to that in 2012?
Keep it short and to the point. 0.98. What is the ratio of the Domestic credit (% of GDP) of Kenya in 2011 to that in 2012?
Offer a very short reply. 1.03. What is the ratio of the Domestic credit (% of GDP) of Trinidad and Tobago in 2011 to that in 2012?
Your answer should be compact. 0.98. What is the ratio of the Domestic credit (% of GDP) in Armenia in 2011 to that in 2013?
Your response must be concise. 0.83. What is the ratio of the Domestic credit (% of GDP) in Kazakhstan in 2011 to that in 2013?
Provide a short and direct response. 1.01. What is the ratio of the Domestic credit (% of GDP) in Kenya in 2011 to that in 2013?
Offer a terse response. 0.96. What is the ratio of the Domestic credit (% of GDP) in Trinidad and Tobago in 2011 to that in 2013?
Offer a terse response. 1.05. What is the ratio of the Domestic credit (% of GDP) of Armenia in 2012 to that in 2013?
Make the answer very short. 0.95. What is the ratio of the Domestic credit (% of GDP) of Kazakhstan in 2012 to that in 2013?
Offer a very short reply. 1.03. What is the ratio of the Domestic credit (% of GDP) in Kenya in 2012 to that in 2013?
Ensure brevity in your answer.  0.93. What is the ratio of the Domestic credit (% of GDP) of Trinidad and Tobago in 2012 to that in 2013?
Your response must be concise. 1.07. What is the difference between the highest and the second highest Domestic credit (% of GDP) in Armenia?
Keep it short and to the point. 2.32. What is the difference between the highest and the second highest Domestic credit (% of GDP) of Kazakhstan?
Provide a short and direct response. 0.62. What is the difference between the highest and the second highest Domestic credit (% of GDP) of Kenya?
Your answer should be very brief. 1.24. What is the difference between the highest and the second highest Domestic credit (% of GDP) of Trinidad and Tobago?
Ensure brevity in your answer.  3.47. What is the difference between the highest and the lowest Domestic credit (% of GDP) of Armenia?
Give a very brief answer. 22.99. What is the difference between the highest and the lowest Domestic credit (% of GDP) in Kazakhstan?
Keep it short and to the point. 14.69. What is the difference between the highest and the lowest Domestic credit (% of GDP) in Kenya?
Provide a short and direct response. 6.79. What is the difference between the highest and the lowest Domestic credit (% of GDP) of Trinidad and Tobago?
Your answer should be very brief. 9.25. 